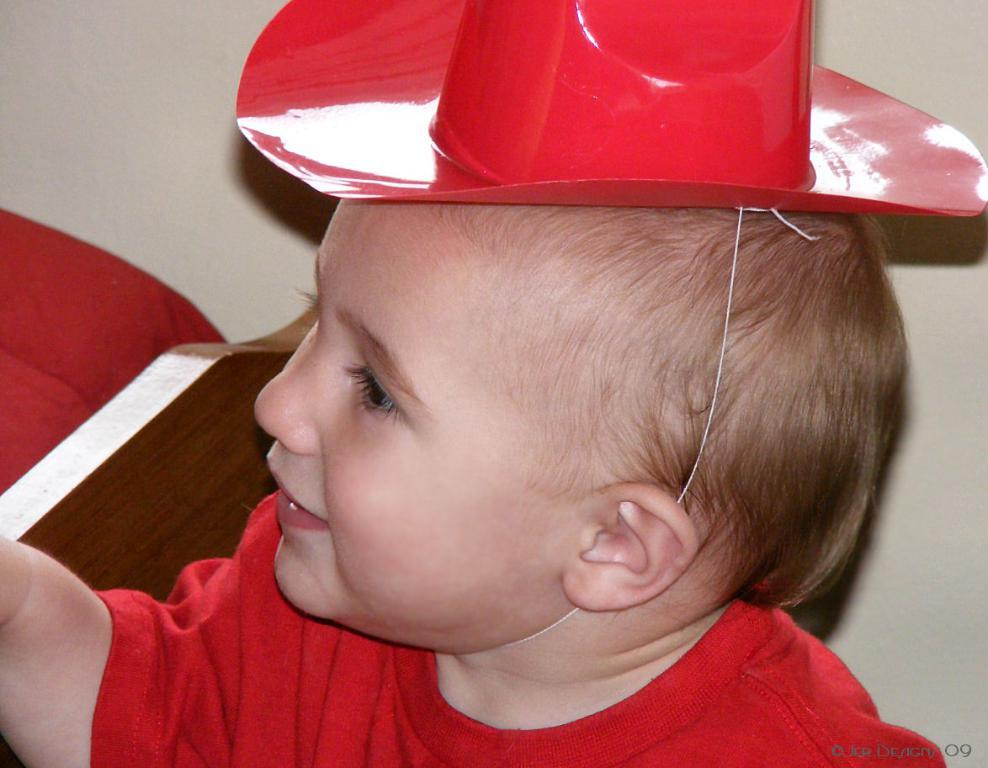What is the main subject of the image? There is a baby in the image. What color are the clothes the baby is wearing? The baby is wearing red clothes. What type of headwear is the baby wearing? The baby is wearing a cap. What expression does the baby have? The baby is smiling. What color is the background of the image? The background of the image is white. What type of pollution is visible in the image? There is no pollution visible in the image; it features a baby wearing red clothes, a cap, and smiling against a white background. 